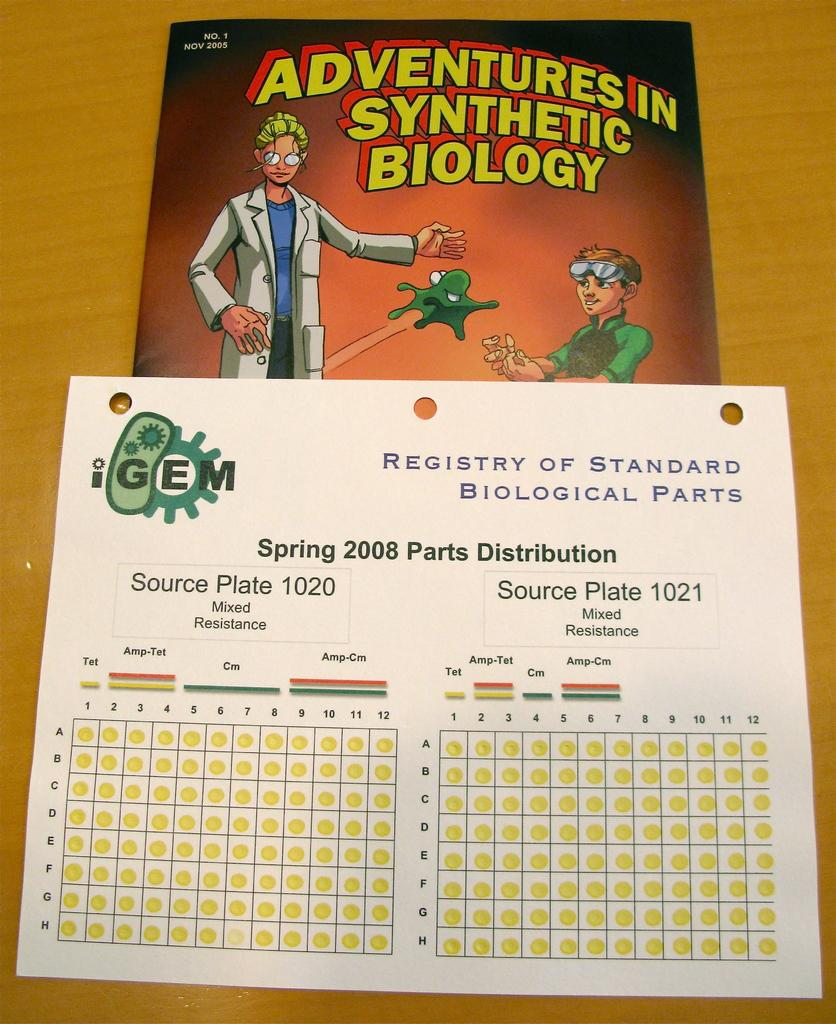Provide a one-sentence caption for the provided image. A book about Adventures in Synthetic Biology was released in Nov 2005. 